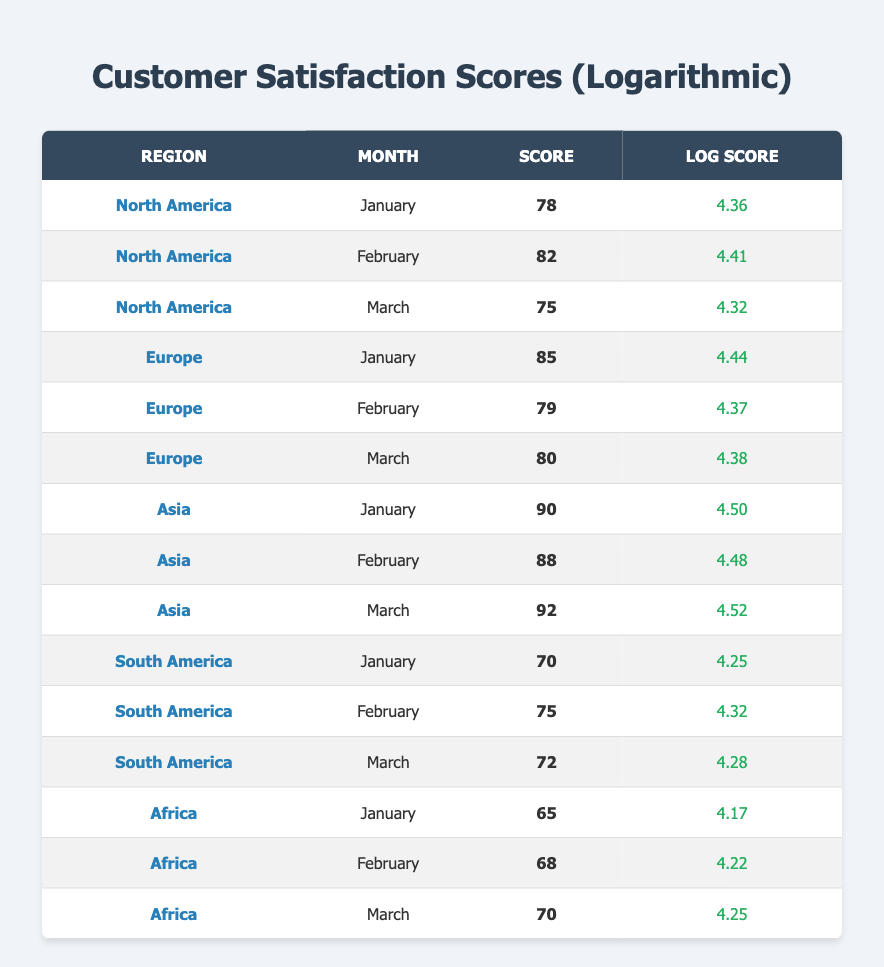What is the customer satisfaction score for Asia in March? The table lists the scores for each region by month. For Asia, the score in March is provided in the corresponding row.
Answer: 92 Which region had the highest satisfaction score in January? By comparing the scores for all regions in January, Asia shows a score of 90, which is higher than the scores for other regions such as North America (78) and Europe (85).
Answer: Asia What is the average customer satisfaction score for South America over the three months? The scores for South America are 70, 75, and 72. Adding these together gives 217. Dividing this sum by the number of months (3) results in an average score of approximately 72.33.
Answer: 72.33 Did Europe have a higher score in February than North America? By checking the February scores, Europe has a score of 79 while North America has a score of 82. Thus, Europe did not have a higher score in February.
Answer: No What is the difference in satisfaction scores between North America and South America in February? North America scored 82 and South America scored 75 in February. The difference is calculated by subtracting the smaller score from the larger one: 82 - 75 = 7.
Answer: 7 Which region consistently scored above 80 across all three months? Looking at the scores for each month, Asia has scores of 90, 88, and 92, all of which are above 80. This is consistent across all months, indicating strong performance in this region.
Answer: Asia What was the satisfaction score trend for Africa from January to March? The scores for Africa across the three months are 65, 68, and 70. Observing these values, it is evident that there is a clear upward trend, showing a gradual increase over the months.
Answer: Upward trend Is there any month where South America's score was lower than Africa's? Comparing the scores, in January South America scored 70 while Africa scored 65. Hence, there is one instance where South America's score was higher than Africa's.
Answer: No What was the highest satisfaction score recorded across all regions and months? By scanning through the entire table, the highest score noted is from Asia in March with a score of 92, which surpasses all other recorded scores in the table.
Answer: 92 